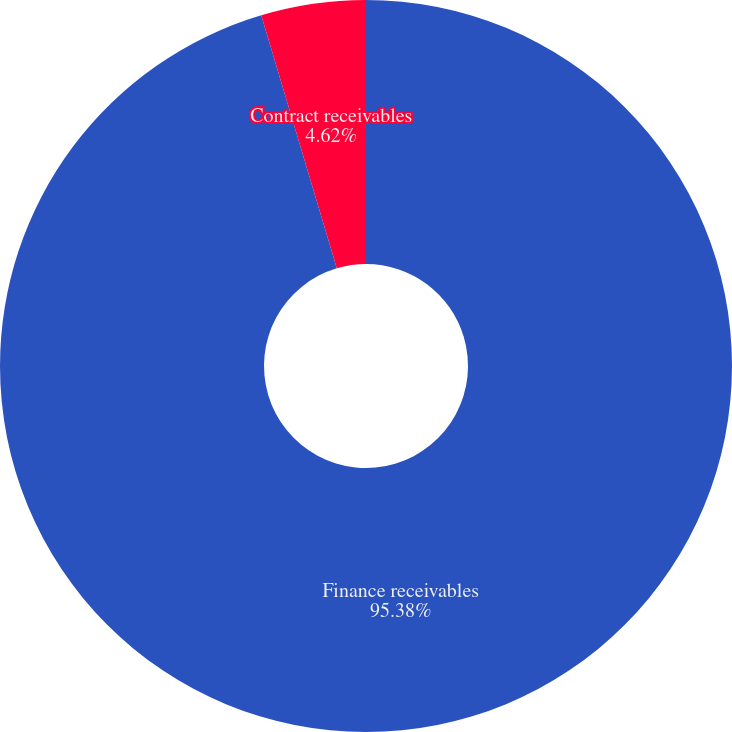Convert chart. <chart><loc_0><loc_0><loc_500><loc_500><pie_chart><fcel>Finance receivables<fcel>Contract receivables<nl><fcel>95.38%<fcel>4.62%<nl></chart> 